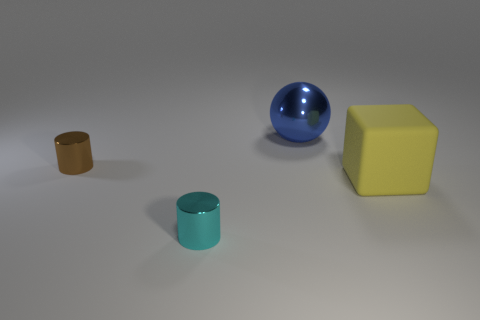What number of brown objects are the same size as the cyan object?
Your response must be concise. 1. Are there an equal number of shiny spheres that are in front of the big yellow rubber thing and brown metallic things?
Give a very brief answer. No. How many things are both to the right of the large blue ball and on the left side of the cyan cylinder?
Your answer should be compact. 0. There is a big thing that is in front of the tiny brown cylinder; is its shape the same as the tiny brown thing?
Provide a succinct answer. No. There is a brown cylinder that is the same size as the cyan cylinder; what material is it?
Make the answer very short. Metal. Are there the same number of cyan cylinders that are in front of the yellow object and cyan metallic cylinders that are to the right of the blue shiny sphere?
Your answer should be very brief. No. What number of big cubes are on the left side of the thing that is right of the big thing that is behind the big yellow rubber cube?
Your answer should be compact. 0. There is a large metallic ball; is it the same color as the small cylinder behind the yellow thing?
Your answer should be compact. No. There is a blue ball that is the same material as the brown object; what is its size?
Provide a succinct answer. Large. Is the number of spheres that are right of the yellow block greater than the number of small cyan things?
Make the answer very short. No. 